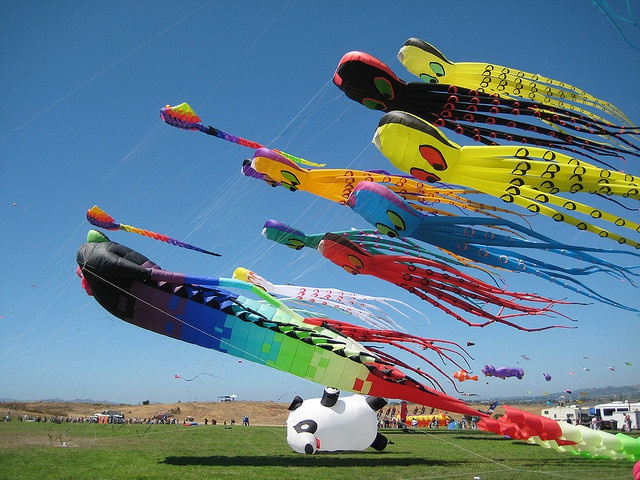Describe the objects in this image and their specific colors. I can see kite in blue, black, lightblue, and lightgray tones, people in blue, darkgreen, lightblue, gray, and tan tones, kite in blue, olive, gold, and black tones, kite in blue, black, gray, and maroon tones, and kite in blue, navy, and darkgray tones in this image. 